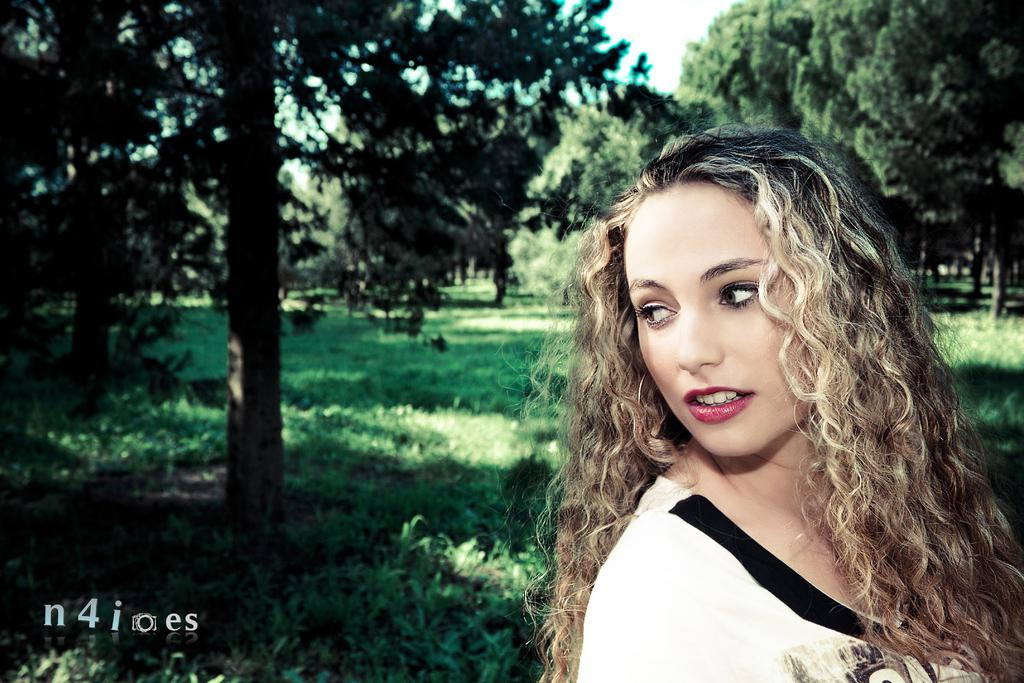Who or what is present in the image? There is a person in the image. What is the person wearing? The person is wearing a white and black dress. What type of natural elements can be seen in the image? There are trees in the image. What is the color of the sky in the image? The sky is white in color. What type of pollution can be seen in the image? There is no pollution visible in the image. What activity is the person engaged in while wearing the white and black dress? The provided facts do not mention any specific activity the person is engaged in. 